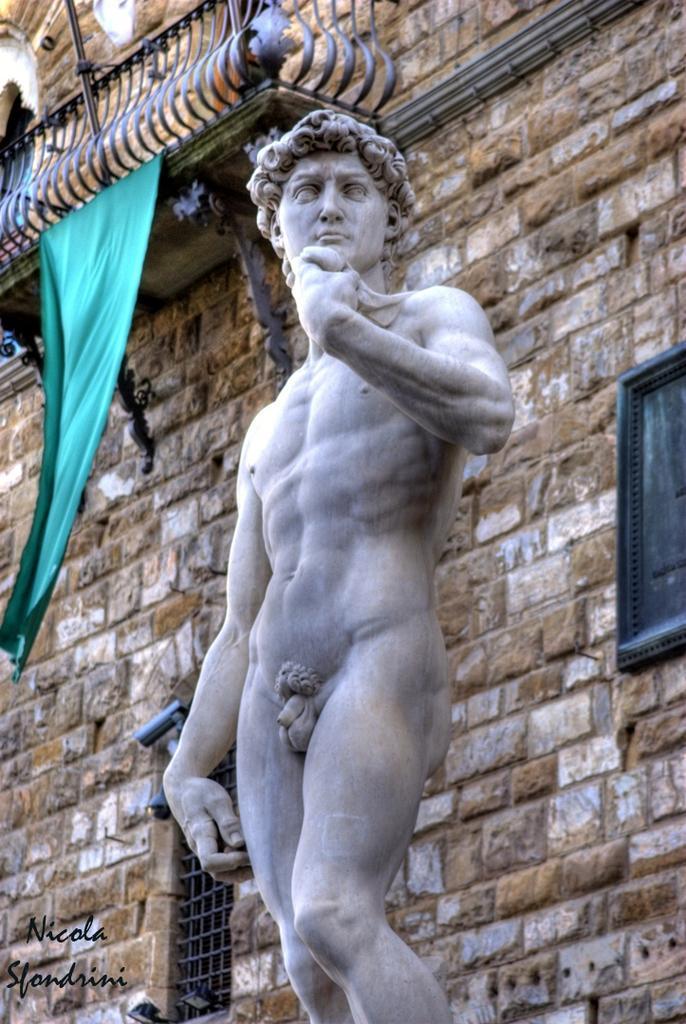Can you describe this image briefly? In this image I can see a person's sculpture, building, windows, cloth, text and balcony. This image is taken may be during a day. 